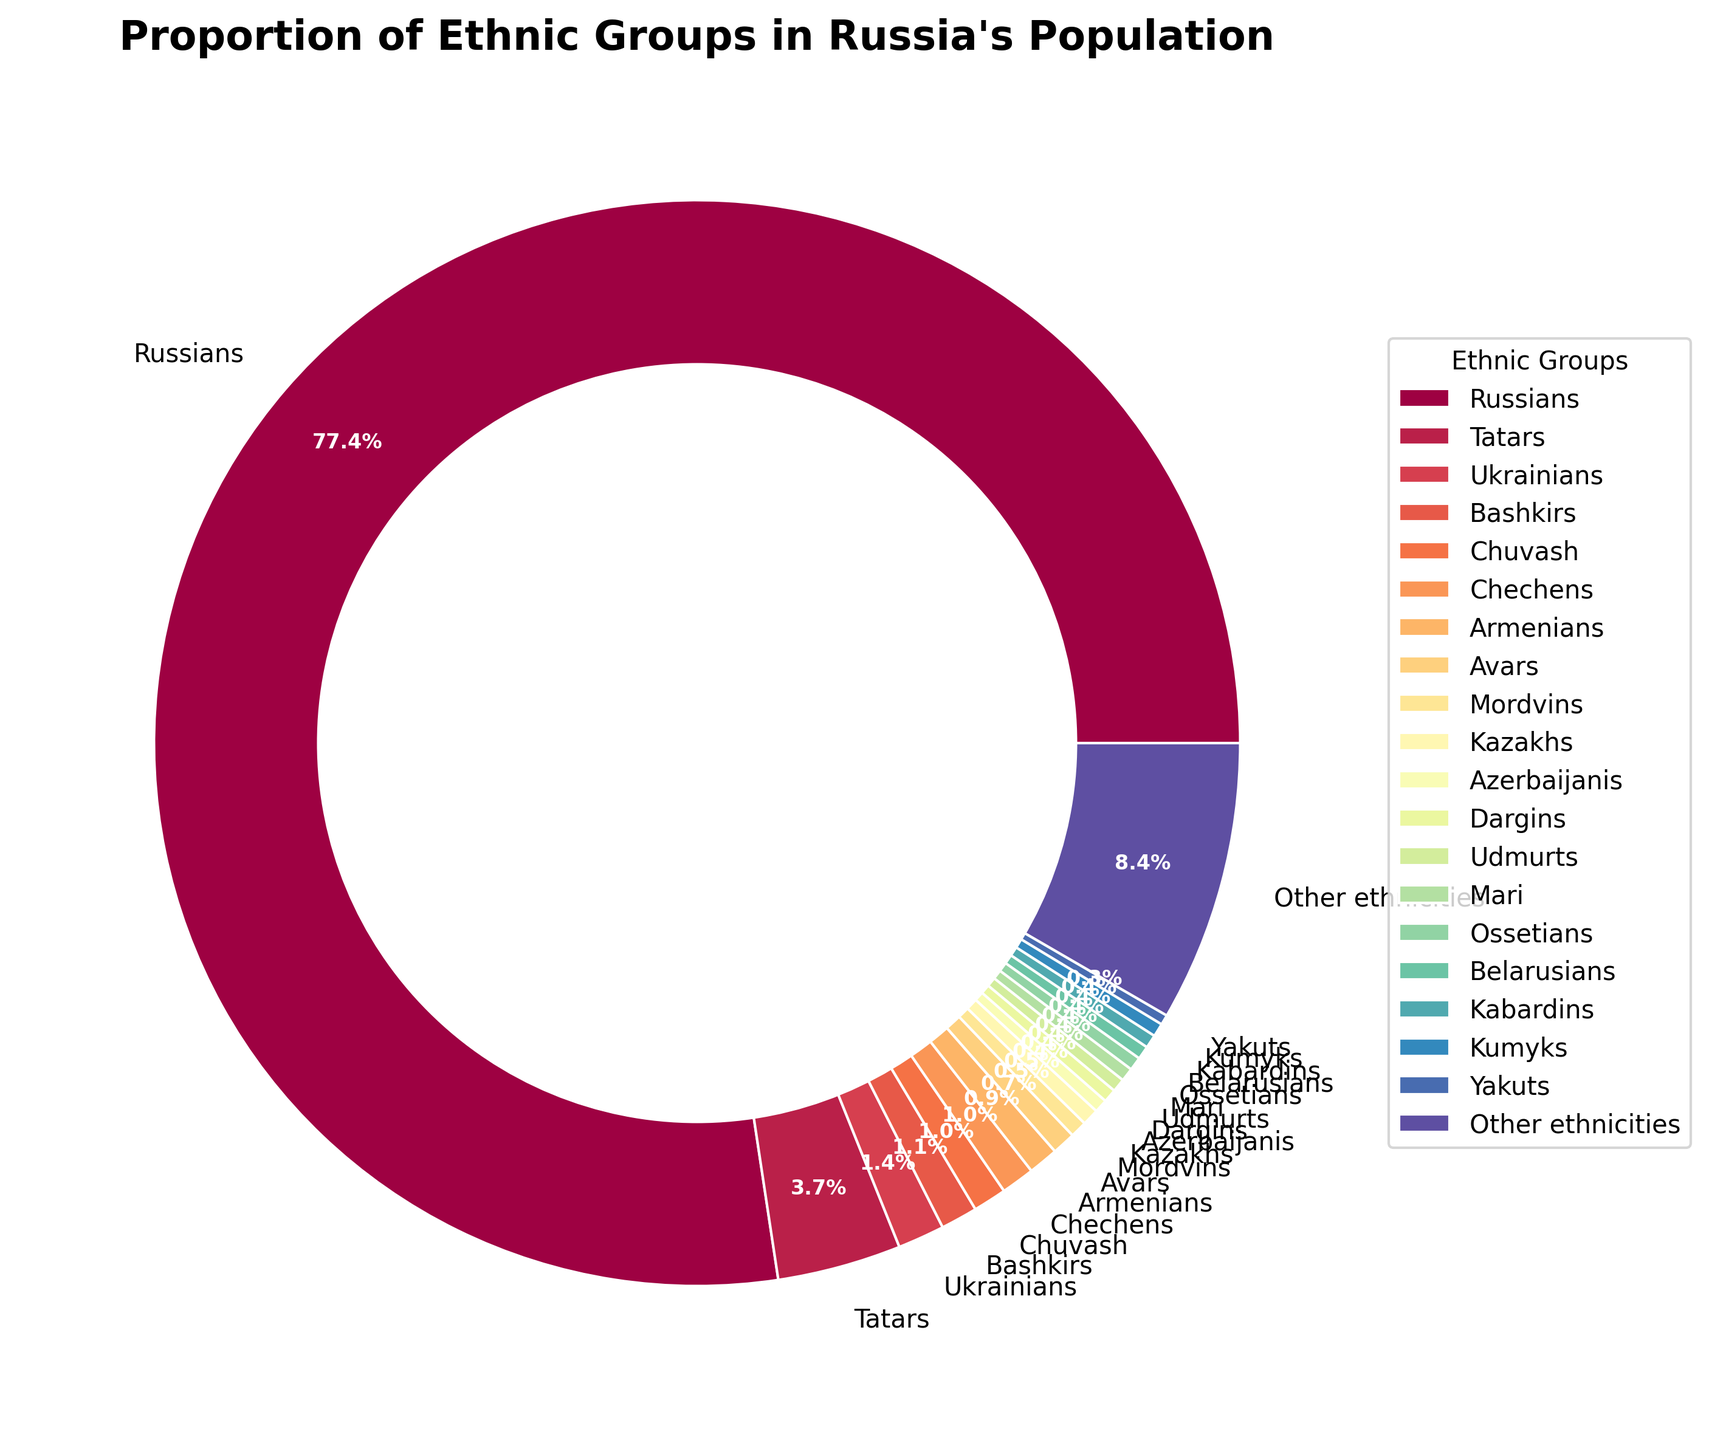What is the percentage of Russians in Russia's population? The pie chart shows that the largest segment, represented by a large wedge, is labeled "Russians" with a percentage indicated. The segment occupies the majority of the pie chart.
Answer: 77.7% How do the percentages of Tatars and Ukrainians compare? The pie chart labels the segment for Tatars as 3.7% and Ukrainians as 1.4%. By comparing these two values, we see that Tatars have a higher percentage than Ukrainians.
Answer: Tatars have a higher percentage than Ukrainians What is the combined percentage of Bashkirs and Chuvash? To find the combined percentage, sum the individual percentages of Bashkirs (1.1%) and Chuvash (1.0%). The pie chart visually represents these values.
Answer: 2.1% Which ethnic group has a larger percentage: Chechens or Armenians? The pie chart shows Chechens and Armenians occupying different segments. Chechens are labeled with a percentage of 1.0%, and Armenians with 0.9%. Comparing the two, Chechens have a slightly higher percentage.
Answer: Chechens What is the sum of the percentages for all ethnic groups that are 0.5% each? The pie chart lists the percentages of four ethnic groups each at 0.5%: Mordvins, Kazakhs, Dargins, and Udmurts. Summing these up: 0.5% + 0.5% + 0.5% + 0.5% = 2.0%.
Answer: 2.0% How does the size of the 'Other ethnicities' segment compare to the entire pie chart? The 'Other ethnicities' segment is labeled as 8.4%, and visually, it occupies a smaller but significant portion of the pie chart. This is less than one-tenth of the entire pie chart, which represents 100%.
Answer: It is less than one-tenth Which three ethnic groups together constitute exactly 1.2% of the population? To find the combination of ethnic groups that sum up to 1.2%, consider groups with smaller percentages. Yakuts (0.3%), Ossetians (0.4%), and Azebaijanis (0.5%) add up as: 0.3% + 0.4% + 0.5% = 1.2%.
Answer: Yakuts, Ossetians, and Azerbaijanis What percentage of the population do the top three ethnic groups represent? The top three ethnic groups are Russians (77.7%), Tatars (3.7%), and Ukrainians (1.4%). Summing these: 77.7% + 3.7% + 1.4% = 82.8%.
Answer: 82.8% What is the difference in percentage between the Bashkirs and the Yakuts? The pie chart shows Bashkirs with 1.1% and Yakuts with 0.3%. The difference can be calculated as 1.1% - 0.3% = 0.8%.
Answer: 0.8% Which segment has the darkest color on the pie chart? In the pie chart, typically, the segments for larger groups tend to have distinct and possibly darker colors. Russians, having the largest percentage, are likely represented with a more pronounced (often darker) color.
Answer: Russians 